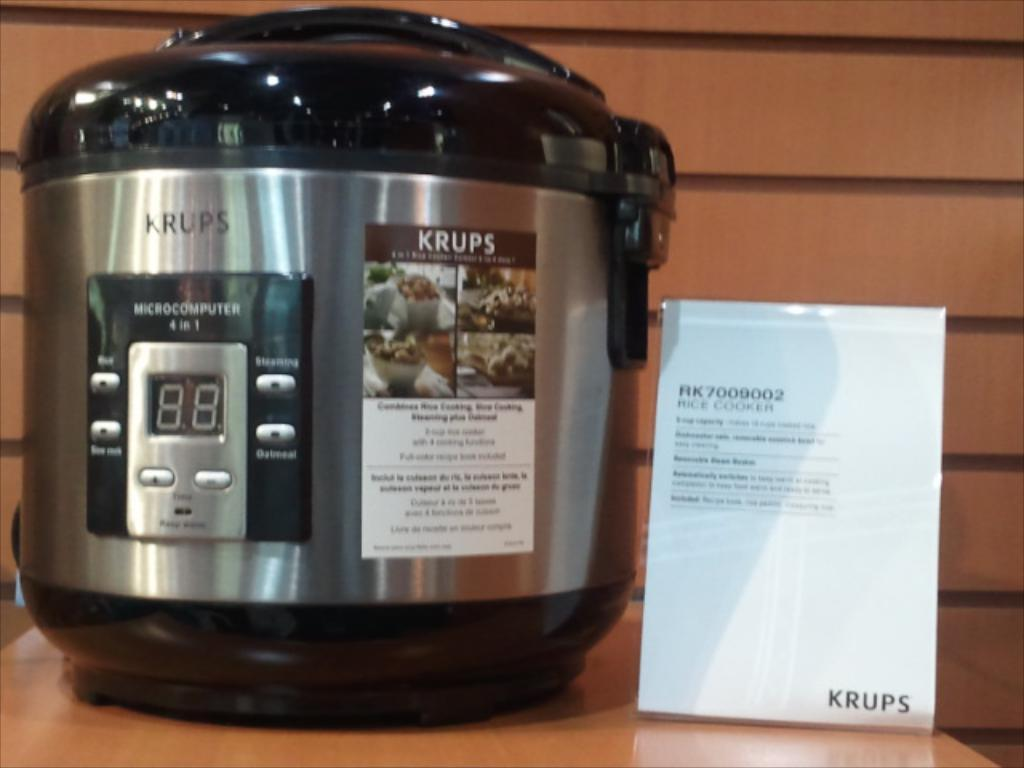<image>
Give a short and clear explanation of the subsequent image. A Krups brand rice cooker on a display for sell. 